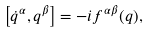<formula> <loc_0><loc_0><loc_500><loc_500>\left [ \dot { q } ^ { \alpha } , q ^ { \beta } \right ] = - i f ^ { \alpha \beta } ( q ) ,</formula> 